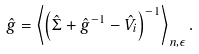<formula> <loc_0><loc_0><loc_500><loc_500>\hat { g } = \left \langle \left ( \hat { \Sigma } + \hat { g } ^ { - 1 } - \hat { V } _ { i } \right ) ^ { - 1 } \right \rangle _ { { n } , \epsilon } .</formula> 